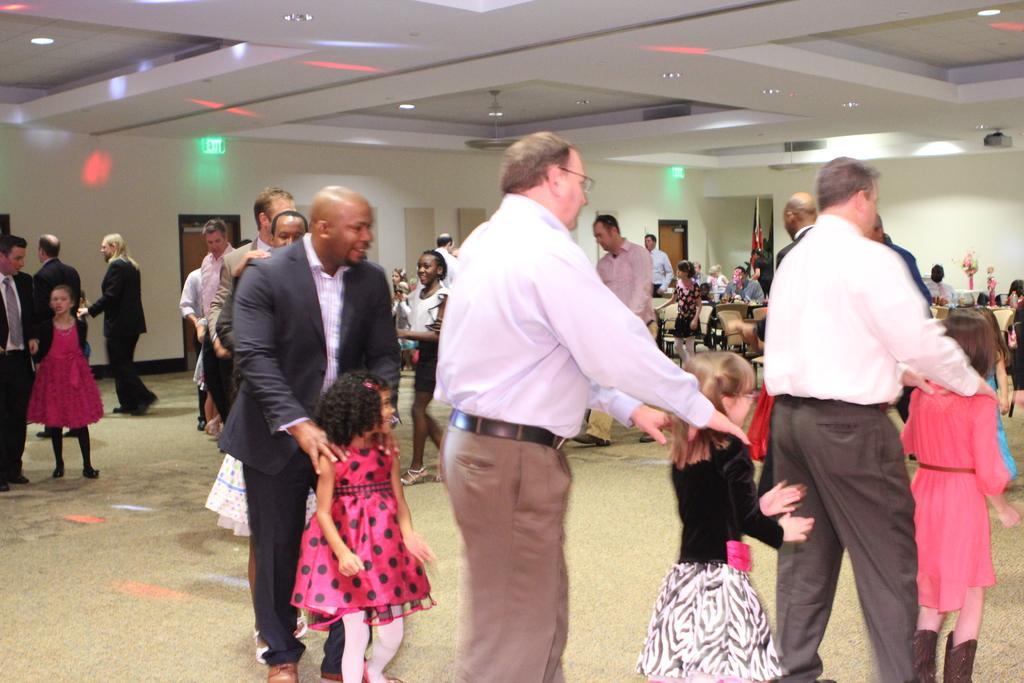Can you describe this image briefly? In this picture I can see the man and children who are playing a game. In the back I can see many people who are sitting on the chairs. On the left I can see some people who are standing near to the doors. Above the door I can see the exit sign board. At the top I can see the lights on lights beams. 